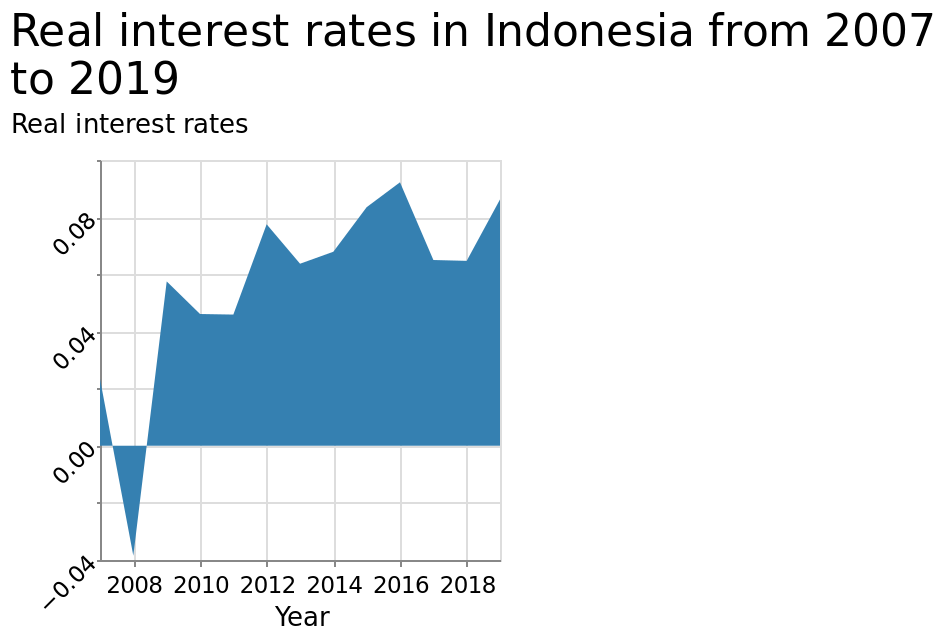<image>
When did interest rates in Indonesia start being over 0.04? Interest rates in Indonesia have been over 0.04 since 2008. What is the range of the y-axis on the graph?  The y-axis measures Real interest rates using a categorical scale from −0.04 to 0.10. please summary the statistics and relations of the chart Since 2008 interest rates have been over 0.04 in Indonesia. Does the y-axis measure Fake interest rates using a numerical scale from −0.04 to 0.10? No. The y-axis measures Real interest rates using a categorical scale from −0.04 to 0.10. 